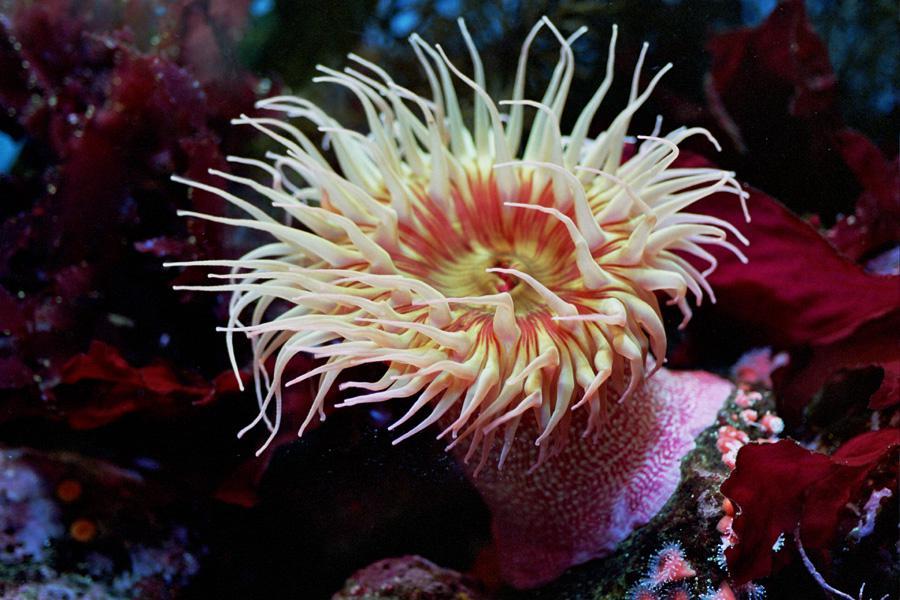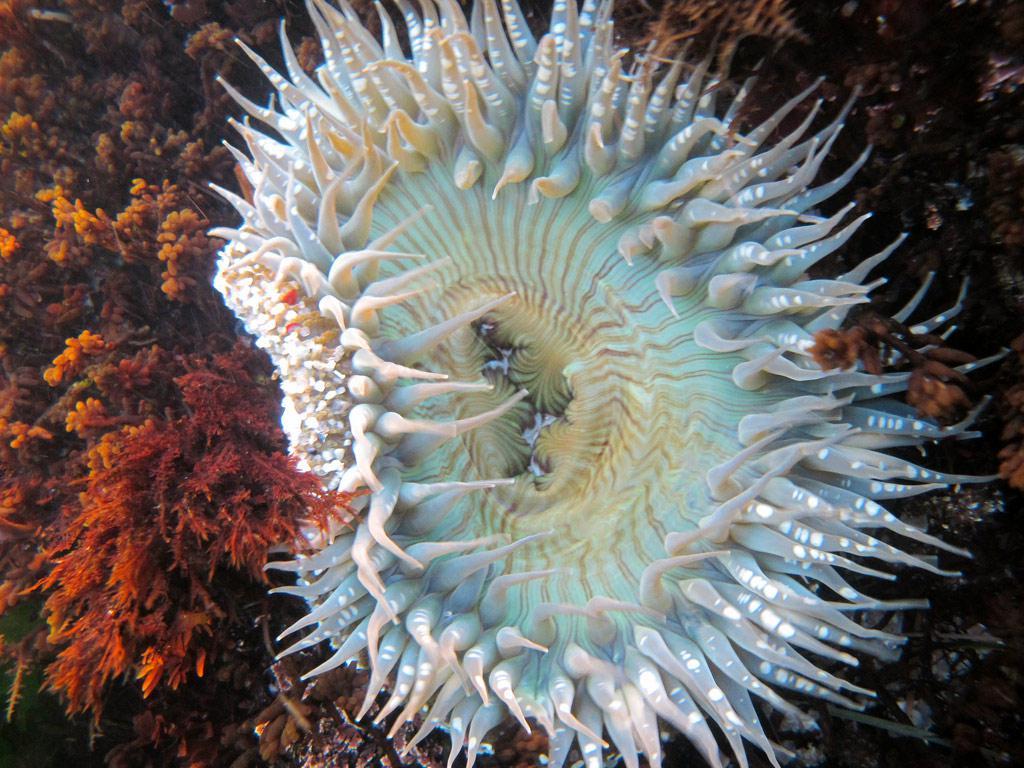The first image is the image on the left, the second image is the image on the right. Assess this claim about the two images: "The anemones in the image on the left have black and white trunks". Correct or not? Answer yes or no. No. The first image is the image on the left, the second image is the image on the right. Examine the images to the left and right. Is the description "An anemone image includes a black-and-white almost zebra-like pattern." accurate? Answer yes or no. No. 